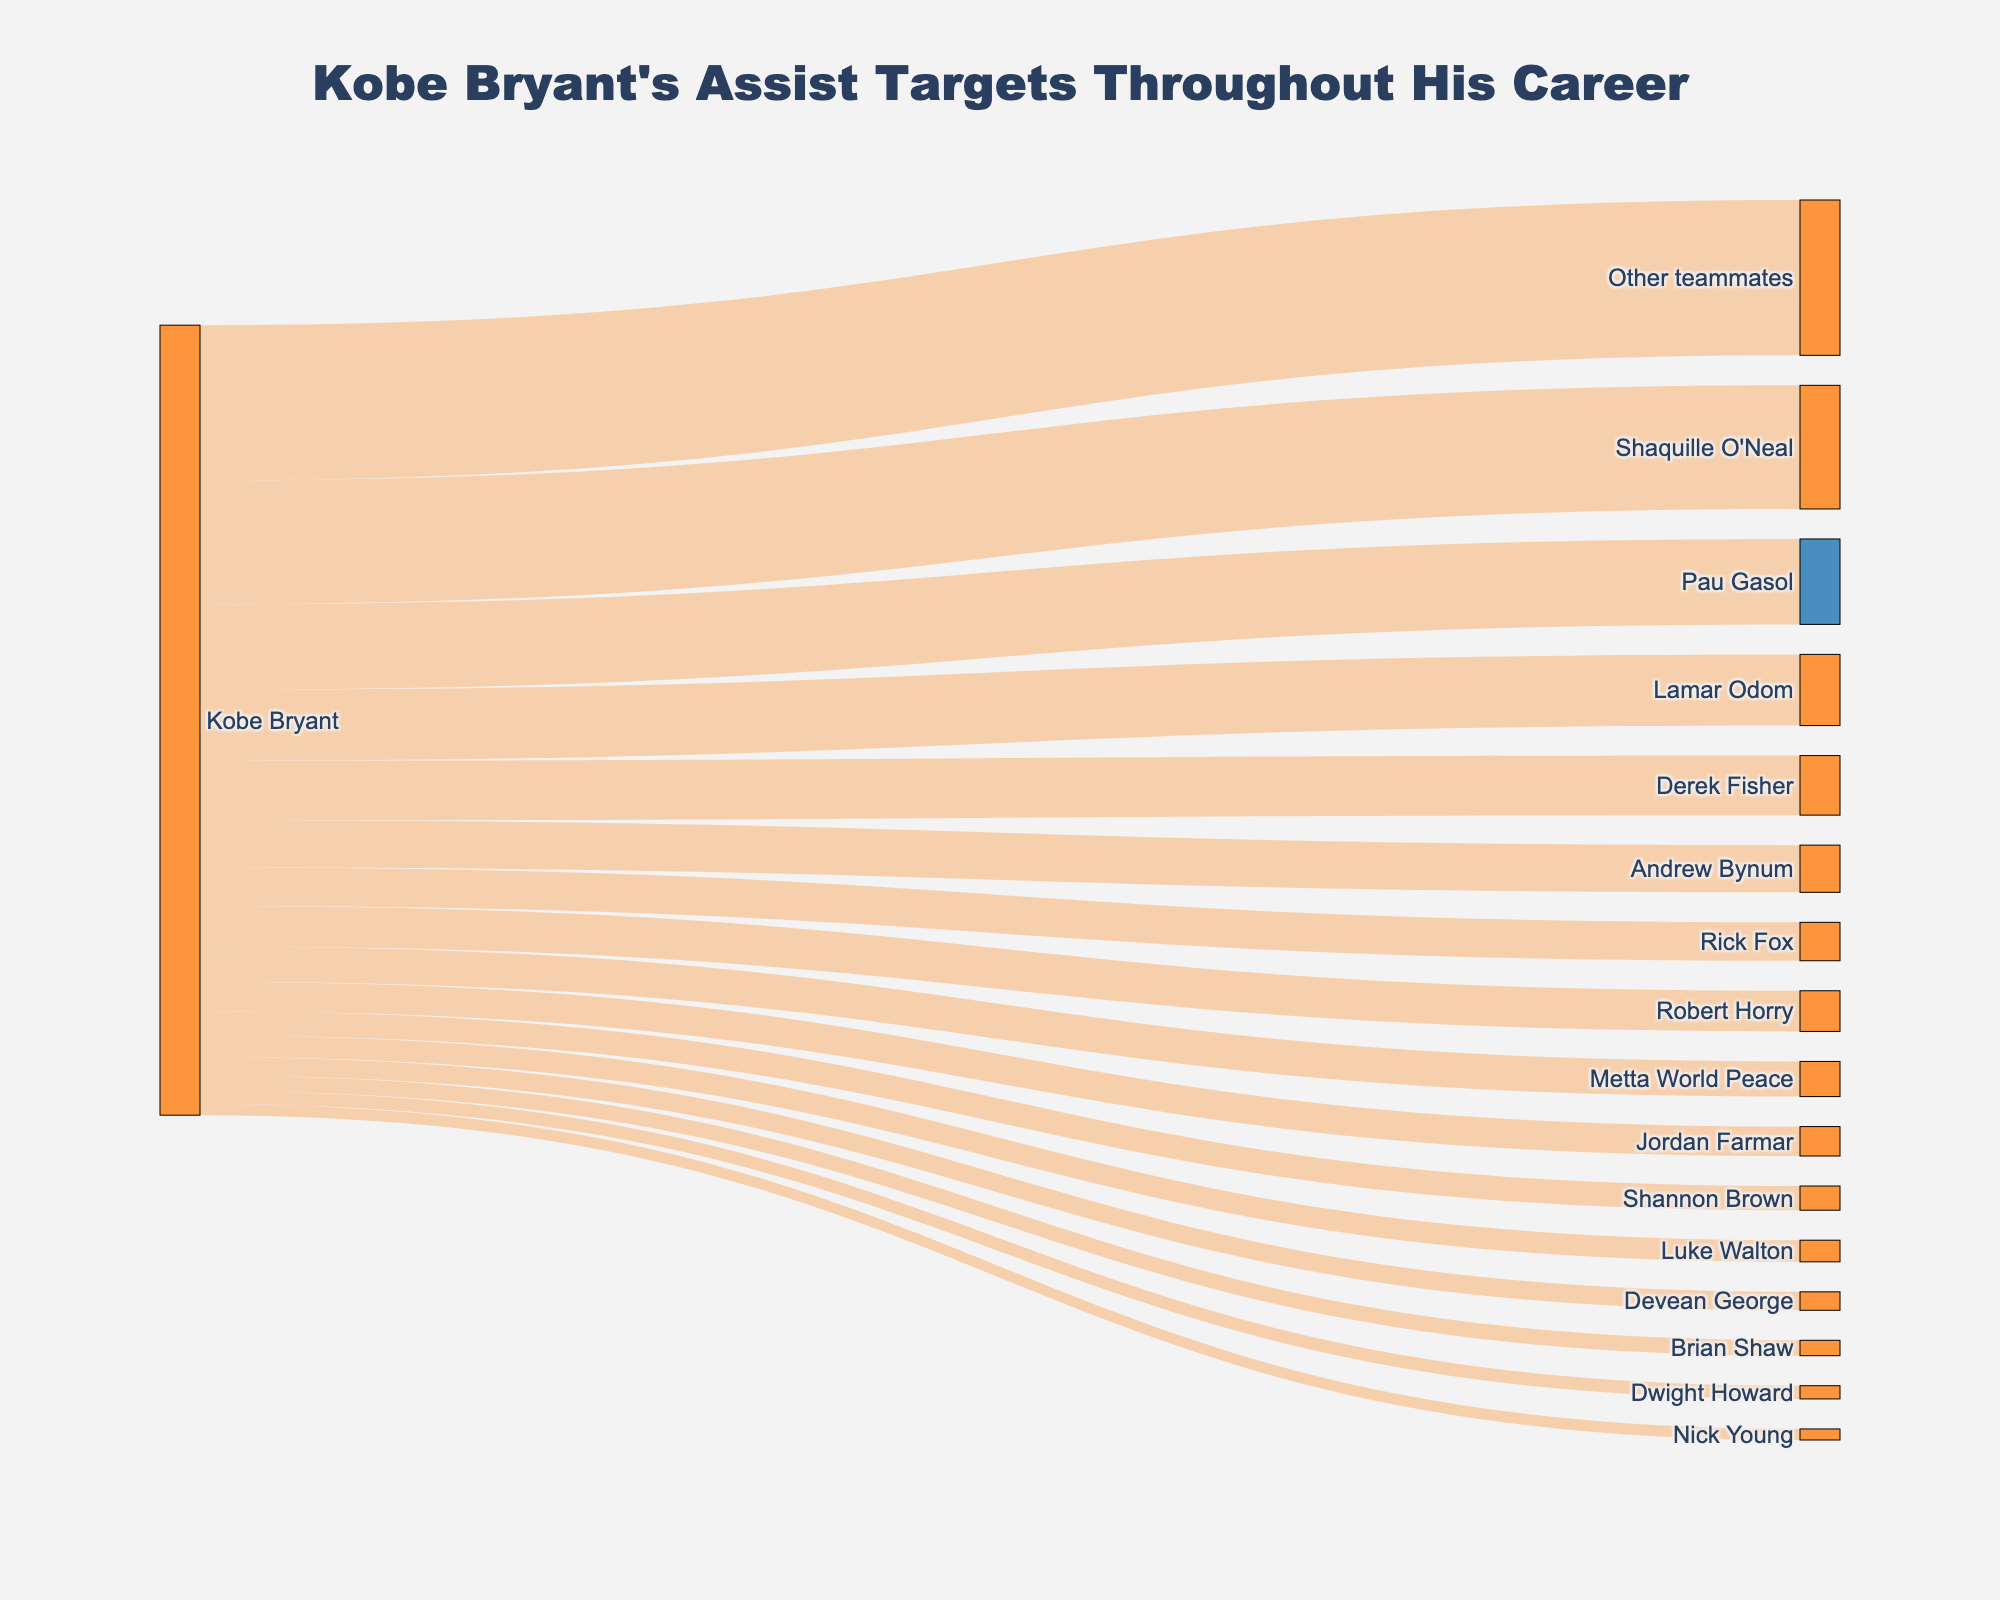what is the title of the Sankey Diagram? The title of the Sankey Diagram is located at the top of the figure and is displayed prominently in a larger font size. By observing this area, one can find the title.
Answer: Kobe Bryant's Assist Targets Throughout His Career How many assist targets does Kobe have in the figure? To find the total number of targets, count the entries under the 'target' column in the data. Each entry represents a distinct assist target.
Answer: 16 Who is Kobe Bryant's top assist target? By looking at the largest value associated with the targets in the Sankey Diagram, you can identify the top assist target.
Answer: Shaquille O'Neal How many assists did Kobe Bryant make to Pau Gasol and Lamar Odom combined? Add the values for Pau Gasol (865) and Lamar Odom (721) to find the combined assists. 865 + 721.
Answer: 1586 Compare the number of assists made to Derek Fisher and Robert Horry, which one received more assists? By comparing the values associated with Derek Fisher (603) and Robert Horry (412) in the Sankey Diagram, you can determine who received more assists.
Answer: Derek Fisher Which teammate received the least number of assists from Kobe Bryant? Identify the smallest value in the Sankey Diagram to find the teammate with the fewest assists.
Answer: Nick Young How many more assists did Shaquille O'Neal receive compared to Andrew Bynum? Subtract the number of assists for Andrew Bynum (478) from that of Shaquille O'Neal (1252) to find the difference. 1252 - 478.
Answer: 774 Among the assist targets, how many received more than 500 assists from Kobe Bryant? Count the number of targets with values greater than 500 in the Sankey Diagram data. These targets are Shaquille O'Neal, Pau Gasol, Lamar Odom, and Derek Fisher.
Answer: 4 What's the average number of assists given to the top 3 assist targets? Identify the values for the top 3 targets (Shaquille O'Neal, Pau Gasol, and Lamar Odom). Calculate the average: (1252 + 865 + 721) / 3.
Answer: 946 Which two assist targets have the closest number of assists from Kobe Bryant? Identify the smallest difference between the values associated with any two targets by comparing all possible pairs.
Answer: Robert Horry and Rick Fox 